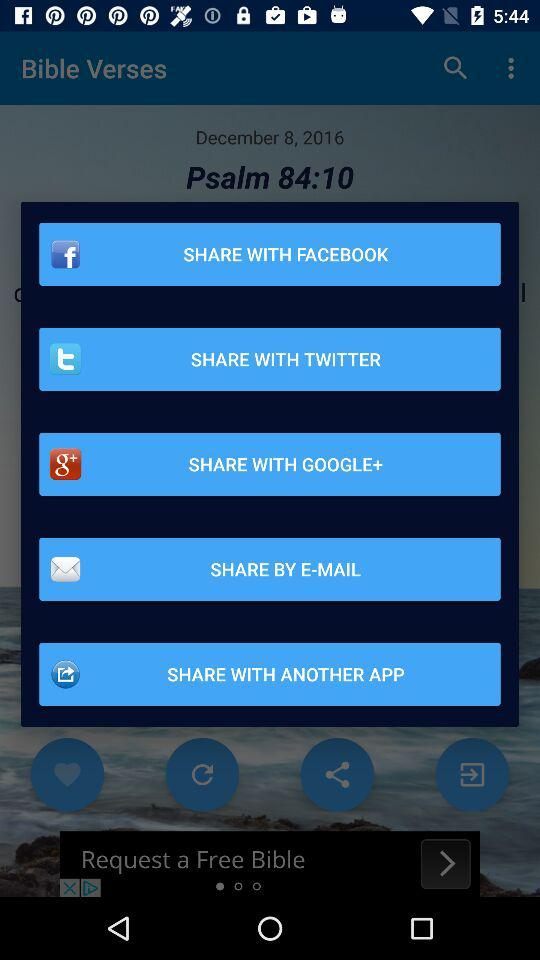What is the given date? The given date is December 8, 2016. 